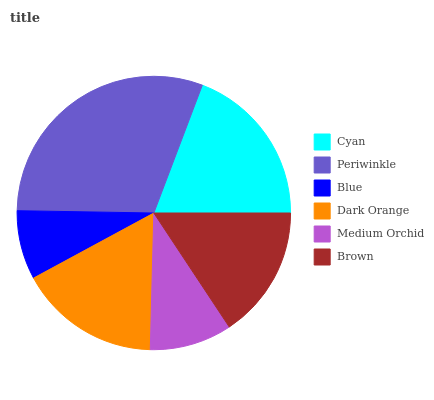Is Blue the minimum?
Answer yes or no. Yes. Is Periwinkle the maximum?
Answer yes or no. Yes. Is Periwinkle the minimum?
Answer yes or no. No. Is Blue the maximum?
Answer yes or no. No. Is Periwinkle greater than Blue?
Answer yes or no. Yes. Is Blue less than Periwinkle?
Answer yes or no. Yes. Is Blue greater than Periwinkle?
Answer yes or no. No. Is Periwinkle less than Blue?
Answer yes or no. No. Is Dark Orange the high median?
Answer yes or no. Yes. Is Brown the low median?
Answer yes or no. Yes. Is Brown the high median?
Answer yes or no. No. Is Dark Orange the low median?
Answer yes or no. No. 